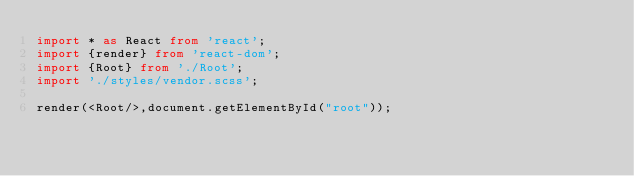<code> <loc_0><loc_0><loc_500><loc_500><_TypeScript_>import * as React from 'react';
import {render} from 'react-dom';
import {Root} from './Root';
import './styles/vendor.scss';

render(<Root/>,document.getElementById("root"));</code> 